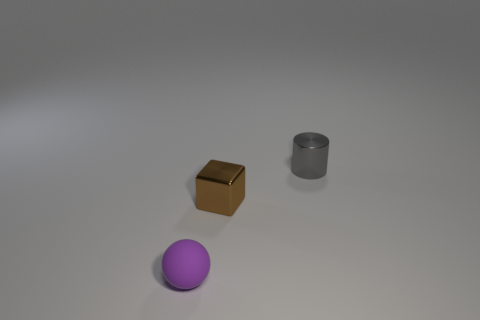Are there any other things that have the same material as the tiny brown thing?
Provide a succinct answer. Yes. What material is the gray thing?
Offer a terse response. Metal. There is a thing that is on the left side of the brown block; what is it made of?
Your response must be concise. Rubber. Are there any other things that are the same color as the small shiny cylinder?
Your response must be concise. No. There is a thing that is the same material as the small cylinder; what is its size?
Your response must be concise. Small. How many big things are either cylinders or red shiny spheres?
Offer a very short reply. 0. How big is the shiny object that is to the left of the small thing on the right side of the shiny thing to the left of the tiny gray shiny cylinder?
Ensure brevity in your answer.  Small. What number of metallic cylinders are the same size as the brown metal cube?
Make the answer very short. 1. How many objects are tiny brown metal things or objects that are in front of the gray cylinder?
Make the answer very short. 2. The small purple object has what shape?
Make the answer very short. Sphere. 